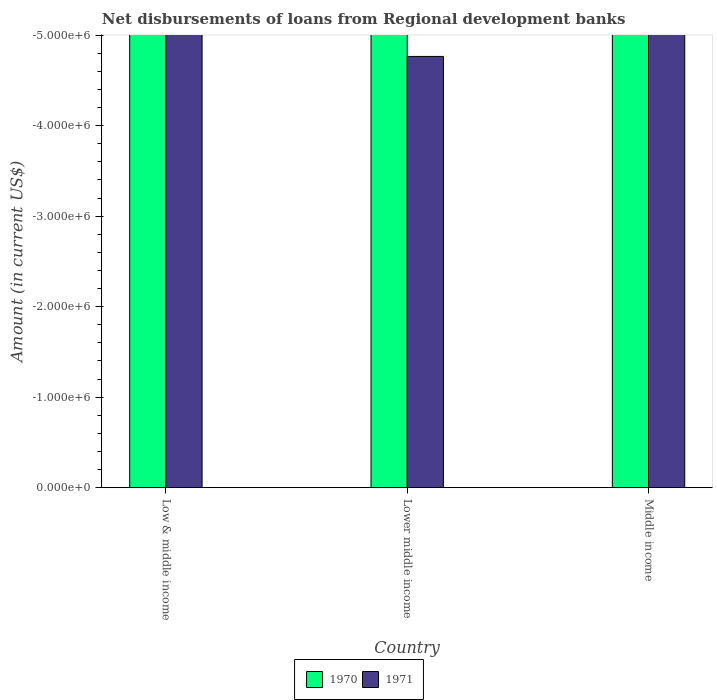How many bars are there on the 1st tick from the left?
Your answer should be compact. 0. What is the label of the 1st group of bars from the left?
Your response must be concise. Low & middle income. What is the amount of disbursements of loans from regional development banks in 1971 in Lower middle income?
Offer a very short reply. 0. What is the total amount of disbursements of loans from regional development banks in 1970 in the graph?
Your answer should be compact. 0. In how many countries, is the amount of disbursements of loans from regional development banks in 1971 greater than the average amount of disbursements of loans from regional development banks in 1971 taken over all countries?
Keep it short and to the point. 0. Are all the bars in the graph horizontal?
Offer a terse response. No. Where does the legend appear in the graph?
Offer a very short reply. Bottom center. How are the legend labels stacked?
Give a very brief answer. Horizontal. What is the title of the graph?
Your response must be concise. Net disbursements of loans from Regional development banks. Does "1982" appear as one of the legend labels in the graph?
Offer a terse response. No. What is the Amount (in current US$) in 1970 in Low & middle income?
Keep it short and to the point. 0. What is the Amount (in current US$) of 1971 in Low & middle income?
Give a very brief answer. 0. What is the Amount (in current US$) in 1970 in Lower middle income?
Your answer should be compact. 0. What is the Amount (in current US$) of 1971 in Lower middle income?
Offer a very short reply. 0. What is the Amount (in current US$) of 1970 in Middle income?
Offer a terse response. 0. What is the Amount (in current US$) of 1971 in Middle income?
Provide a short and direct response. 0. What is the total Amount (in current US$) in 1970 in the graph?
Keep it short and to the point. 0. What is the average Amount (in current US$) of 1971 per country?
Offer a terse response. 0. 